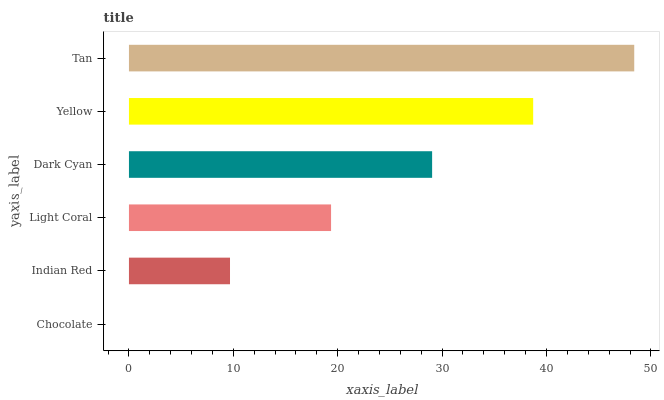Is Chocolate the minimum?
Answer yes or no. Yes. Is Tan the maximum?
Answer yes or no. Yes. Is Indian Red the minimum?
Answer yes or no. No. Is Indian Red the maximum?
Answer yes or no. No. Is Indian Red greater than Chocolate?
Answer yes or no. Yes. Is Chocolate less than Indian Red?
Answer yes or no. Yes. Is Chocolate greater than Indian Red?
Answer yes or no. No. Is Indian Red less than Chocolate?
Answer yes or no. No. Is Dark Cyan the high median?
Answer yes or no. Yes. Is Light Coral the low median?
Answer yes or no. Yes. Is Chocolate the high median?
Answer yes or no. No. Is Yellow the low median?
Answer yes or no. No. 